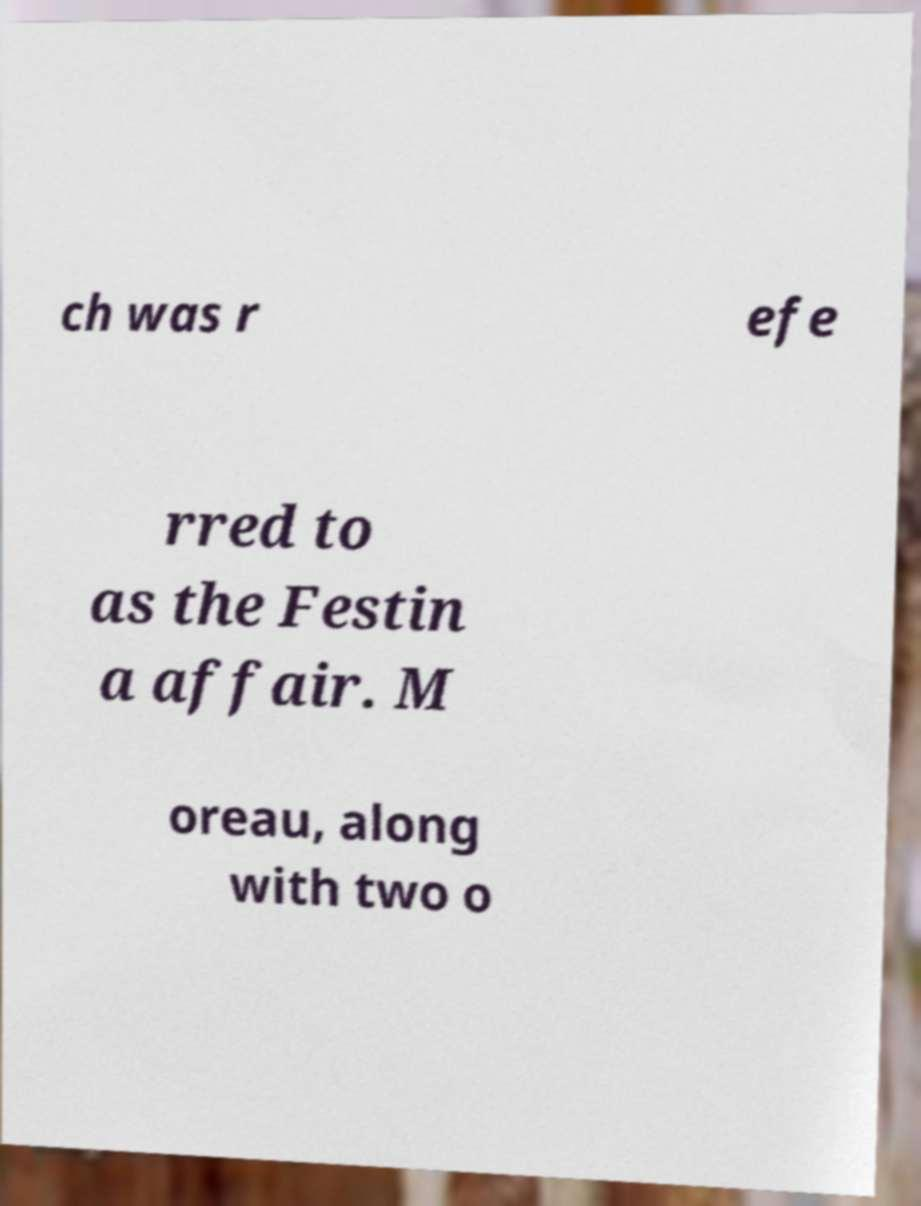I need the written content from this picture converted into text. Can you do that? ch was r efe rred to as the Festin a affair. M oreau, along with two o 